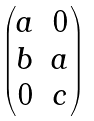Convert formula to latex. <formula><loc_0><loc_0><loc_500><loc_500>\begin{pmatrix} a & 0 \\ b & a \\ 0 & c \\ \end{pmatrix}</formula> 